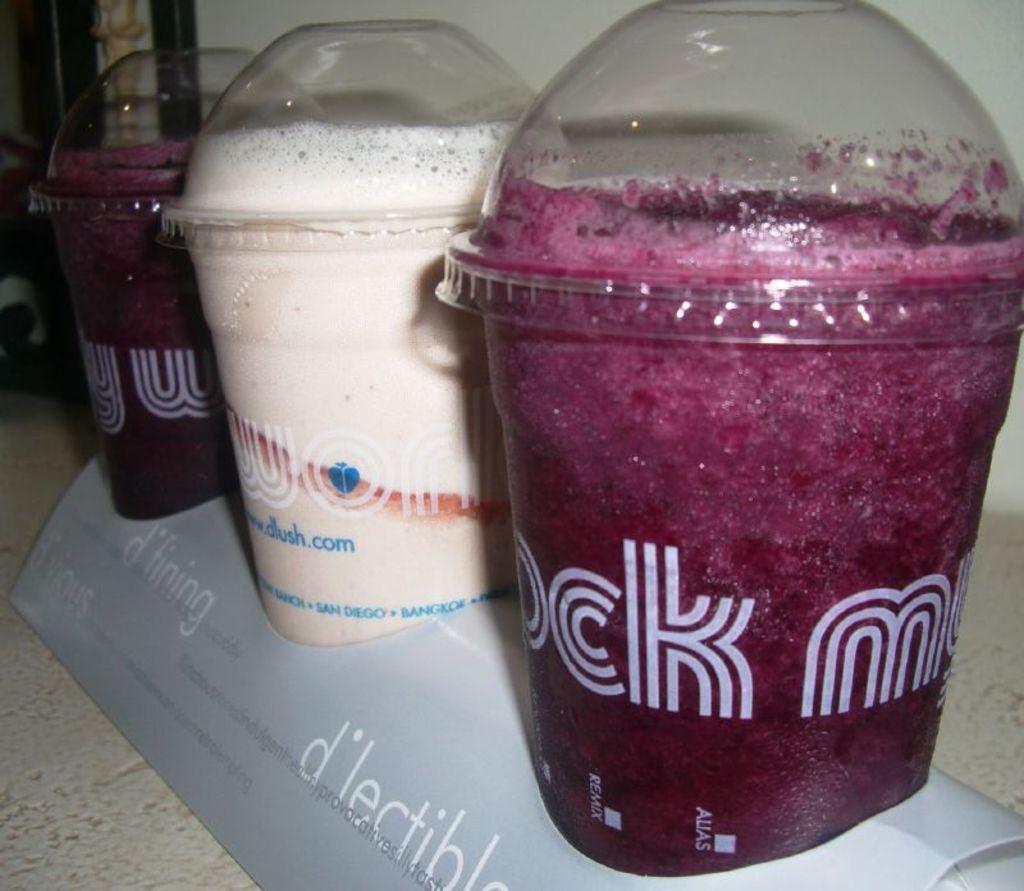What is the web address on the cup?
Keep it short and to the point. Www.dlush.com. What is the word underneath the nearest red drink?
Offer a very short reply. D'lectible. 